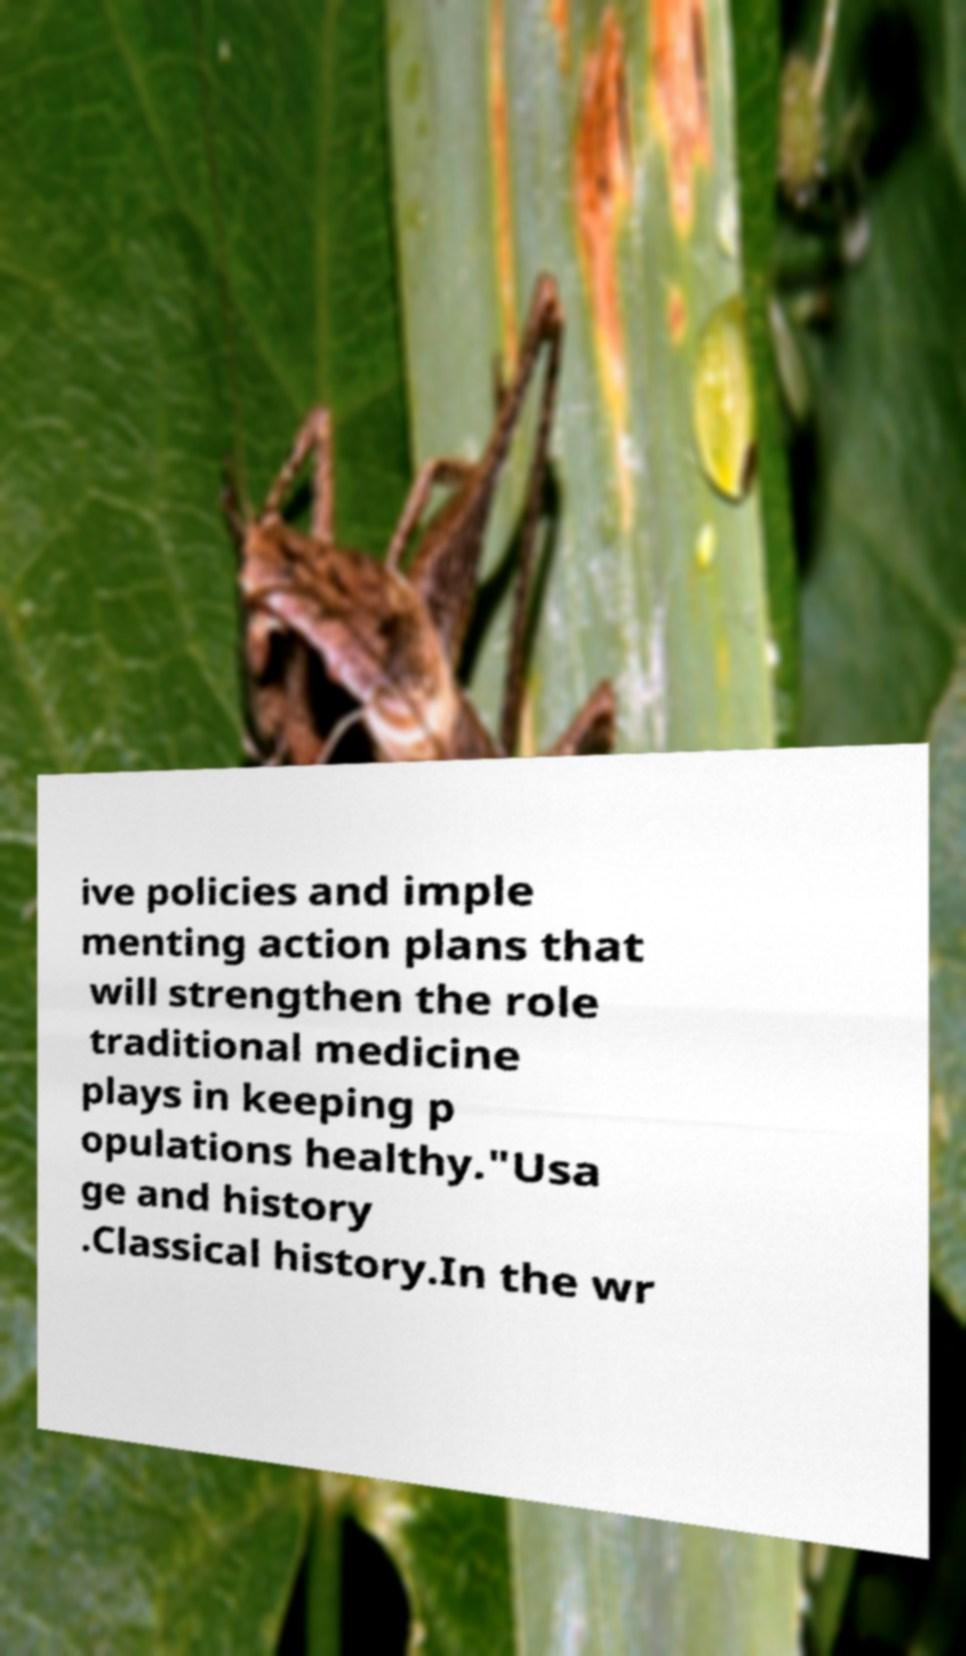Can you accurately transcribe the text from the provided image for me? ive policies and imple menting action plans that will strengthen the role traditional medicine plays in keeping p opulations healthy."Usa ge and history .Classical history.In the wr 